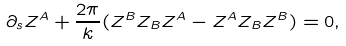Convert formula to latex. <formula><loc_0><loc_0><loc_500><loc_500>\partial _ { s } Z ^ { A } + \frac { 2 \pi } { k } ( Z ^ { B } Z _ { B } Z ^ { A } - Z ^ { A } Z _ { B } Z ^ { B } ) = 0 ,</formula> 